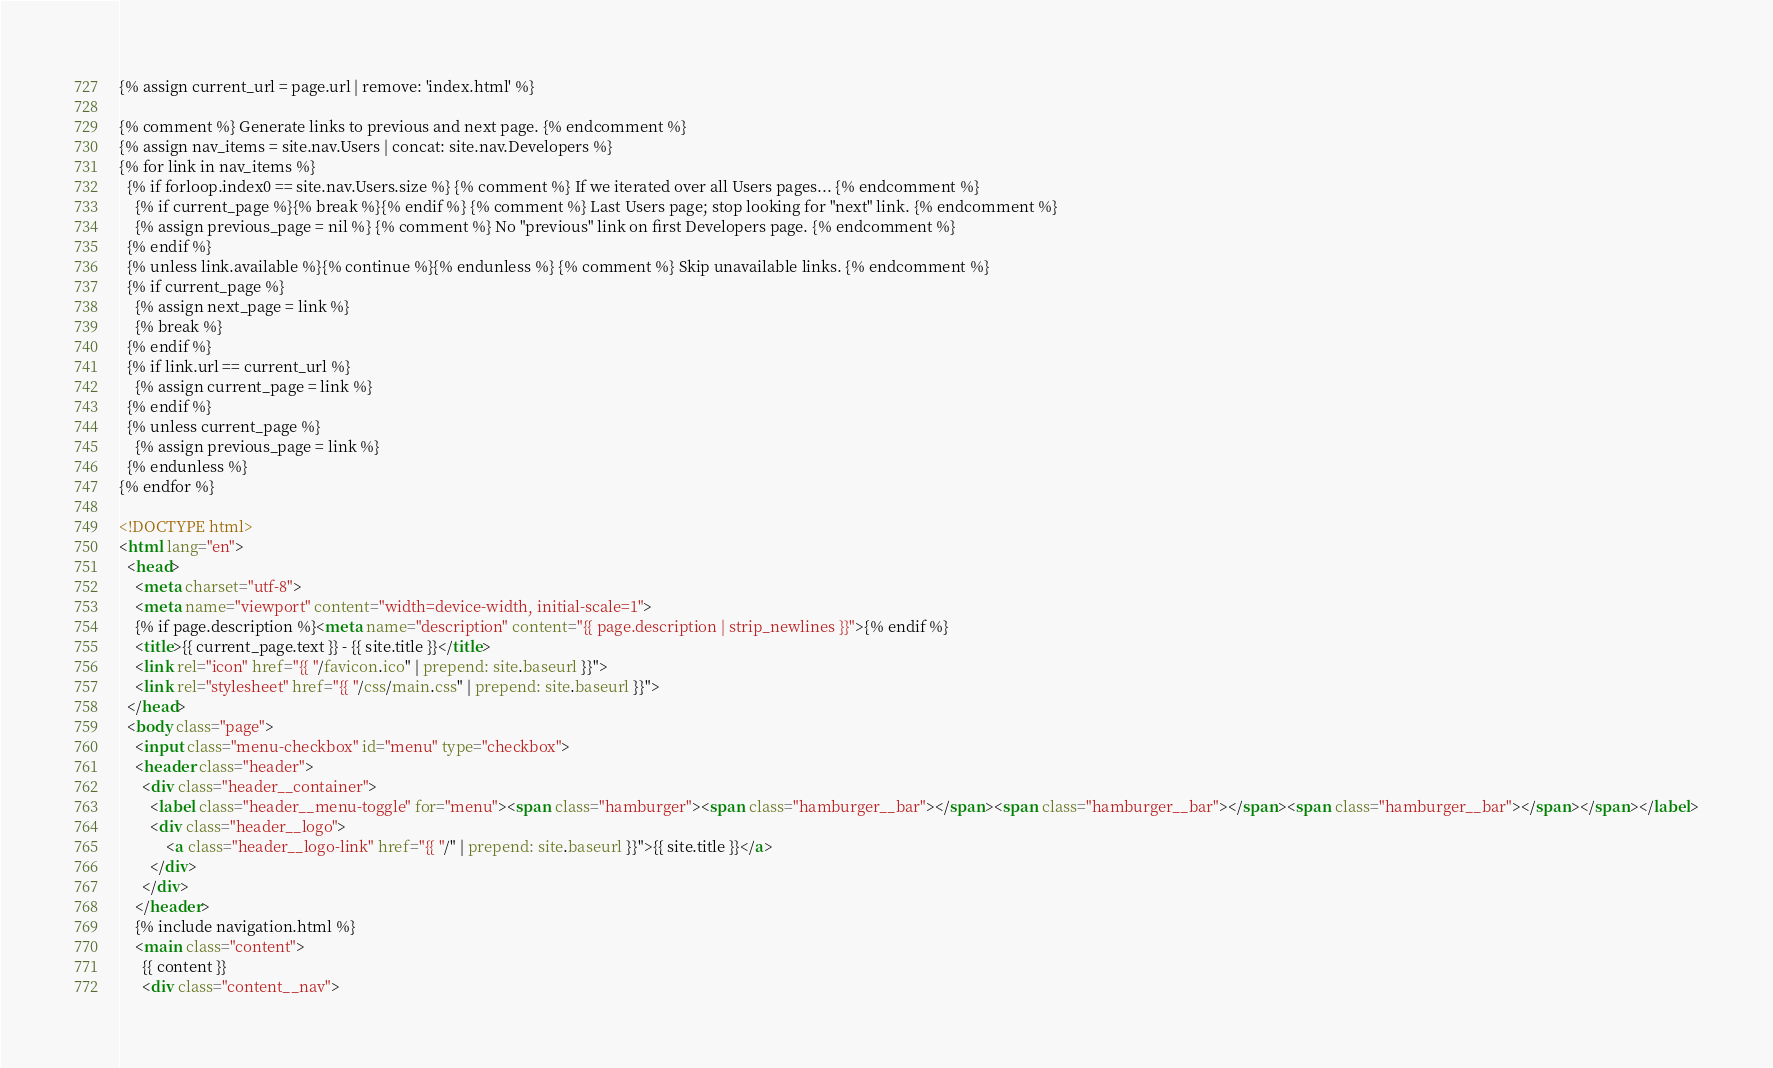Convert code to text. <code><loc_0><loc_0><loc_500><loc_500><_HTML_>{% assign current_url = page.url | remove: 'index.html' %}

{% comment %} Generate links to previous and next page. {% endcomment %}
{% assign nav_items = site.nav.Users | concat: site.nav.Developers %}
{% for link in nav_items %}
  {% if forloop.index0 == site.nav.Users.size %} {% comment %} If we iterated over all Users pages... {% endcomment %}
    {% if current_page %}{% break %}{% endif %} {% comment %} Last Users page; stop looking for "next" link. {% endcomment %}
    {% assign previous_page = nil %} {% comment %} No "previous" link on first Developers page. {% endcomment %}
  {% endif %}
  {% unless link.available %}{% continue %}{% endunless %} {% comment %} Skip unavailable links. {% endcomment %}
  {% if current_page %}
    {% assign next_page = link %}
    {% break %}
  {% endif %}
  {% if link.url == current_url %}
    {% assign current_page = link %}
  {% endif %}
  {% unless current_page %}
    {% assign previous_page = link %}
  {% endunless %}
{% endfor %}

<!DOCTYPE html>
<html lang="en">
  <head>
    <meta charset="utf-8">
    <meta name="viewport" content="width=device-width, initial-scale=1">
    {% if page.description %}<meta name="description" content="{{ page.description | strip_newlines }}">{% endif %}
    <title>{{ current_page.text }} - {{ site.title }}</title>
    <link rel="icon" href="{{ "/favicon.ico" | prepend: site.baseurl }}">
    <link rel="stylesheet" href="{{ "/css/main.css" | prepend: site.baseurl }}">
  </head>
  <body class="page">
    <input class="menu-checkbox" id="menu" type="checkbox">
    <header class="header">
      <div class="header__container">
        <label class="header__menu-toggle" for="menu"><span class="hamburger"><span class="hamburger__bar"></span><span class="hamburger__bar"></span><span class="hamburger__bar"></span></span></label>
        <div class="header__logo">
            <a class="header__logo-link" href="{{ "/" | prepend: site.baseurl }}">{{ site.title }}</a>
        </div>
      </div>
    </header>
    {% include navigation.html %}
    <main class="content">
      {{ content }}
      <div class="content__nav"></code> 